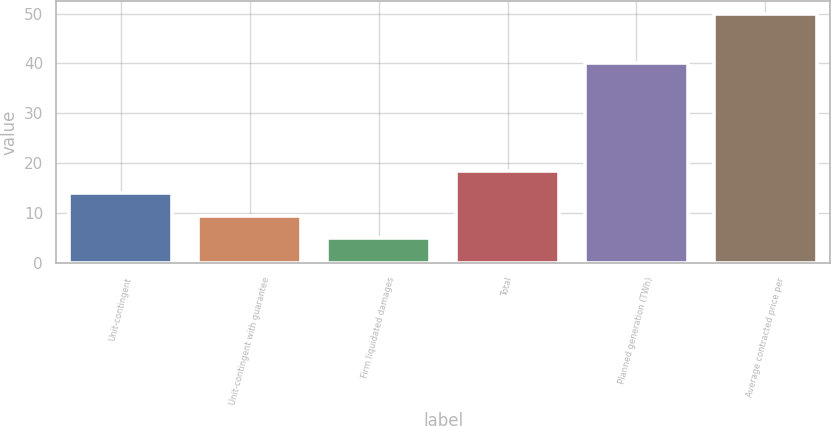Convert chart to OTSL. <chart><loc_0><loc_0><loc_500><loc_500><bar_chart><fcel>Unit-contingent<fcel>Unit-contingent with guarantee<fcel>Firm liquidated damages<fcel>Total<fcel>Planned generation (TWh)<fcel>Average contracted price per<nl><fcel>13.97<fcel>9.47<fcel>4.97<fcel>18.47<fcel>40<fcel>50<nl></chart> 